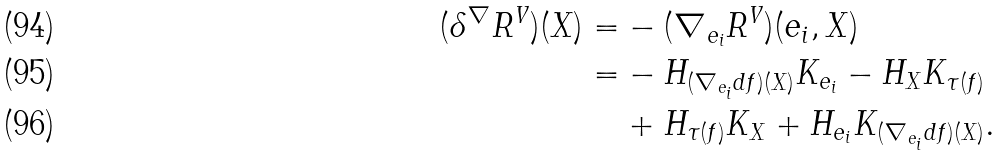Convert formula to latex. <formula><loc_0><loc_0><loc_500><loc_500>( \delta ^ { \nabla } R ^ { V } ) ( X ) = & - ( \nabla _ { e _ { i } } R ^ { V } ) ( e _ { i } , X ) \\ = & - H _ { ( \nabla _ { e _ { i } } d f ) ( X ) } K _ { e _ { i } } - H _ { X } K _ { \tau ( f ) } \\ & + H _ { \tau ( f ) } K _ { X } + H _ { e _ { i } } K _ { ( \nabla _ { e _ { i } } d f ) ( X ) } .</formula> 